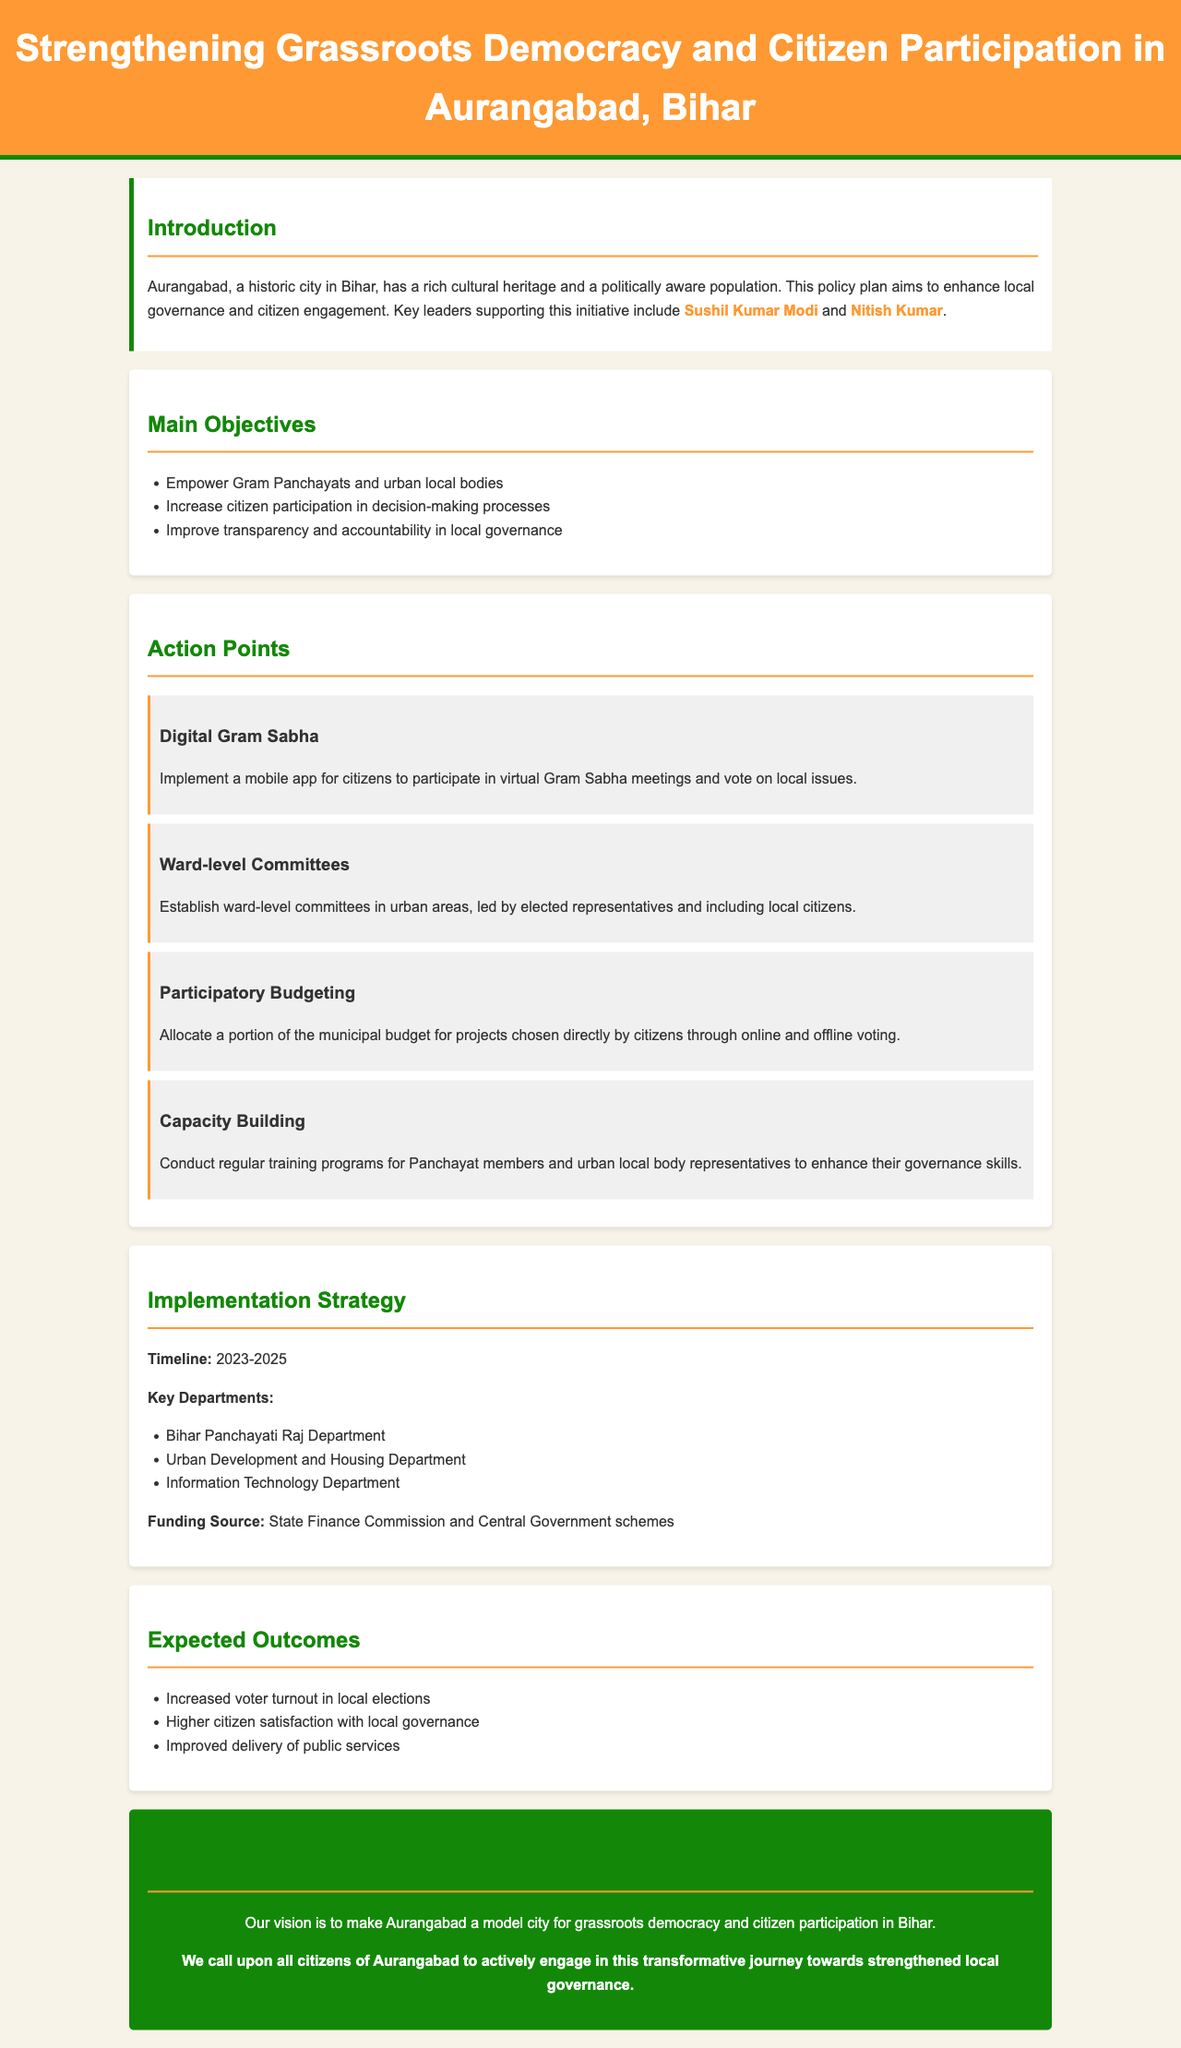What is the main title of the document? The title of the document is clearly stated in the header section, which summarizes the focus on grassroots democracy and citizen participation.
Answer: Strengthening Grassroots Democracy and Citizen Participation in Aurangabad, Bihar Who are the key leaders supporting this initiative? The document mentions two prominent leaders who are backing the policy initiative, highlighting their roles in local governance.
Answer: Sushil Kumar Modi and Nitish Kumar What is the timeline for the implementation of the policy? The document specifies the period during which the policy is planned to be implemented, providing a clear time frame.
Answer: 2023-2025 What is one of the main objectives of the policy plan? The document lists several objectives, focusing on the empowerment and participation of local governance structures.
Answer: Empower Gram Panchayats and urban local bodies What action point involves the use of technology? The action points in the document describe various strategies, notably including one that utilizes digital tools for citizen engagement.
Answer: Digital Gram Sabha Which department is responsible for the policy's implementation? The text identifies several key departments that will be involved in the execution of the policy, highlighting their areas of responsibility.
Answer: Bihar Panchayati Raj Department What is one expected outcome of this policy plan? The document outlines several anticipated achievements of the policy, indicating improvements in civic engagement and governance.
Answer: Increased voter turnout in local elections What funding source is mentioned for the policy? The policy document discusses how the initiatives will be funded, indicating reliance on specific financial bodies.
Answer: State Finance Commission and Central Government schemes What is the concluding message of the document? The conclusion summarizes the overarching vision and call to action for the citizens of Aurangabad, encouraging their participation.
Answer: We call upon all citizens of Aurangabad to actively engage in this transformative journey towards strengthened local governance 